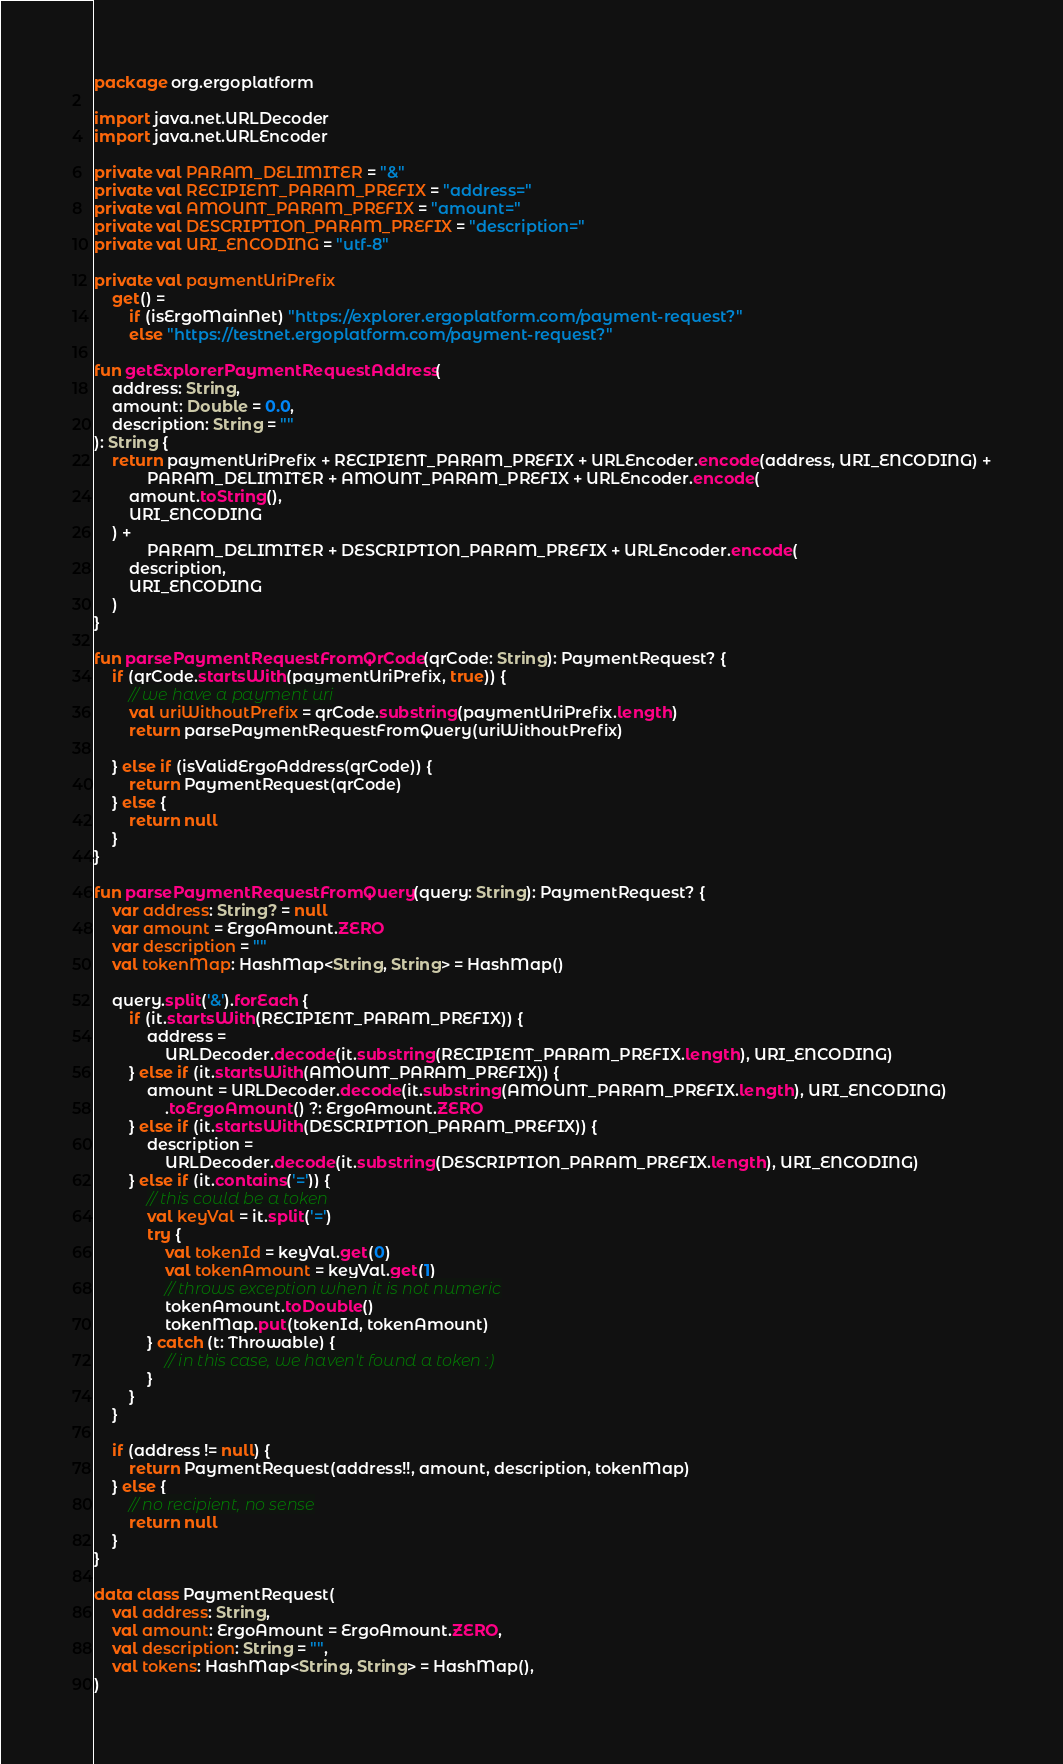<code> <loc_0><loc_0><loc_500><loc_500><_Kotlin_>package org.ergoplatform

import java.net.URLDecoder
import java.net.URLEncoder

private val PARAM_DELIMITER = "&"
private val RECIPIENT_PARAM_PREFIX = "address="
private val AMOUNT_PARAM_PREFIX = "amount="
private val DESCRIPTION_PARAM_PREFIX = "description="
private val URI_ENCODING = "utf-8"

private val paymentUriPrefix
    get() =
        if (isErgoMainNet) "https://explorer.ergoplatform.com/payment-request?"
        else "https://testnet.ergoplatform.com/payment-request?"

fun getExplorerPaymentRequestAddress(
    address: String,
    amount: Double = 0.0,
    description: String = ""
): String {
    return paymentUriPrefix + RECIPIENT_PARAM_PREFIX + URLEncoder.encode(address, URI_ENCODING) +
            PARAM_DELIMITER + AMOUNT_PARAM_PREFIX + URLEncoder.encode(
        amount.toString(),
        URI_ENCODING
    ) +
            PARAM_DELIMITER + DESCRIPTION_PARAM_PREFIX + URLEncoder.encode(
        description,
        URI_ENCODING
    )
}

fun parsePaymentRequestFromQrCode(qrCode: String): PaymentRequest? {
    if (qrCode.startsWith(paymentUriPrefix, true)) {
        // we have a payment uri
        val uriWithoutPrefix = qrCode.substring(paymentUriPrefix.length)
        return parsePaymentRequestFromQuery(uriWithoutPrefix)

    } else if (isValidErgoAddress(qrCode)) {
        return PaymentRequest(qrCode)
    } else {
        return null
    }
}

fun parsePaymentRequestFromQuery(query: String): PaymentRequest? {
    var address: String? = null
    var amount = ErgoAmount.ZERO
    var description = ""
    val tokenMap: HashMap<String, String> = HashMap()

    query.split('&').forEach {
        if (it.startsWith(RECIPIENT_PARAM_PREFIX)) {
            address =
                URLDecoder.decode(it.substring(RECIPIENT_PARAM_PREFIX.length), URI_ENCODING)
        } else if (it.startsWith(AMOUNT_PARAM_PREFIX)) {
            amount = URLDecoder.decode(it.substring(AMOUNT_PARAM_PREFIX.length), URI_ENCODING)
                .toErgoAmount() ?: ErgoAmount.ZERO
        } else if (it.startsWith(DESCRIPTION_PARAM_PREFIX)) {
            description =
                URLDecoder.decode(it.substring(DESCRIPTION_PARAM_PREFIX.length), URI_ENCODING)
        } else if (it.contains('=')) {
            // this could be a token
            val keyVal = it.split('=')
            try {
                val tokenId = keyVal.get(0)
                val tokenAmount = keyVal.get(1)
                // throws exception when it is not numeric
                tokenAmount.toDouble()
                tokenMap.put(tokenId, tokenAmount)
            } catch (t: Throwable) {
                // in this case, we haven't found a token :)
            }
        }
    }

    if (address != null) {
        return PaymentRequest(address!!, amount, description, tokenMap)
    } else {
        // no recipient, no sense
        return null
    }
}

data class PaymentRequest(
    val address: String,
    val amount: ErgoAmount = ErgoAmount.ZERO,
    val description: String = "",
    val tokens: HashMap<String, String> = HashMap(),
)</code> 